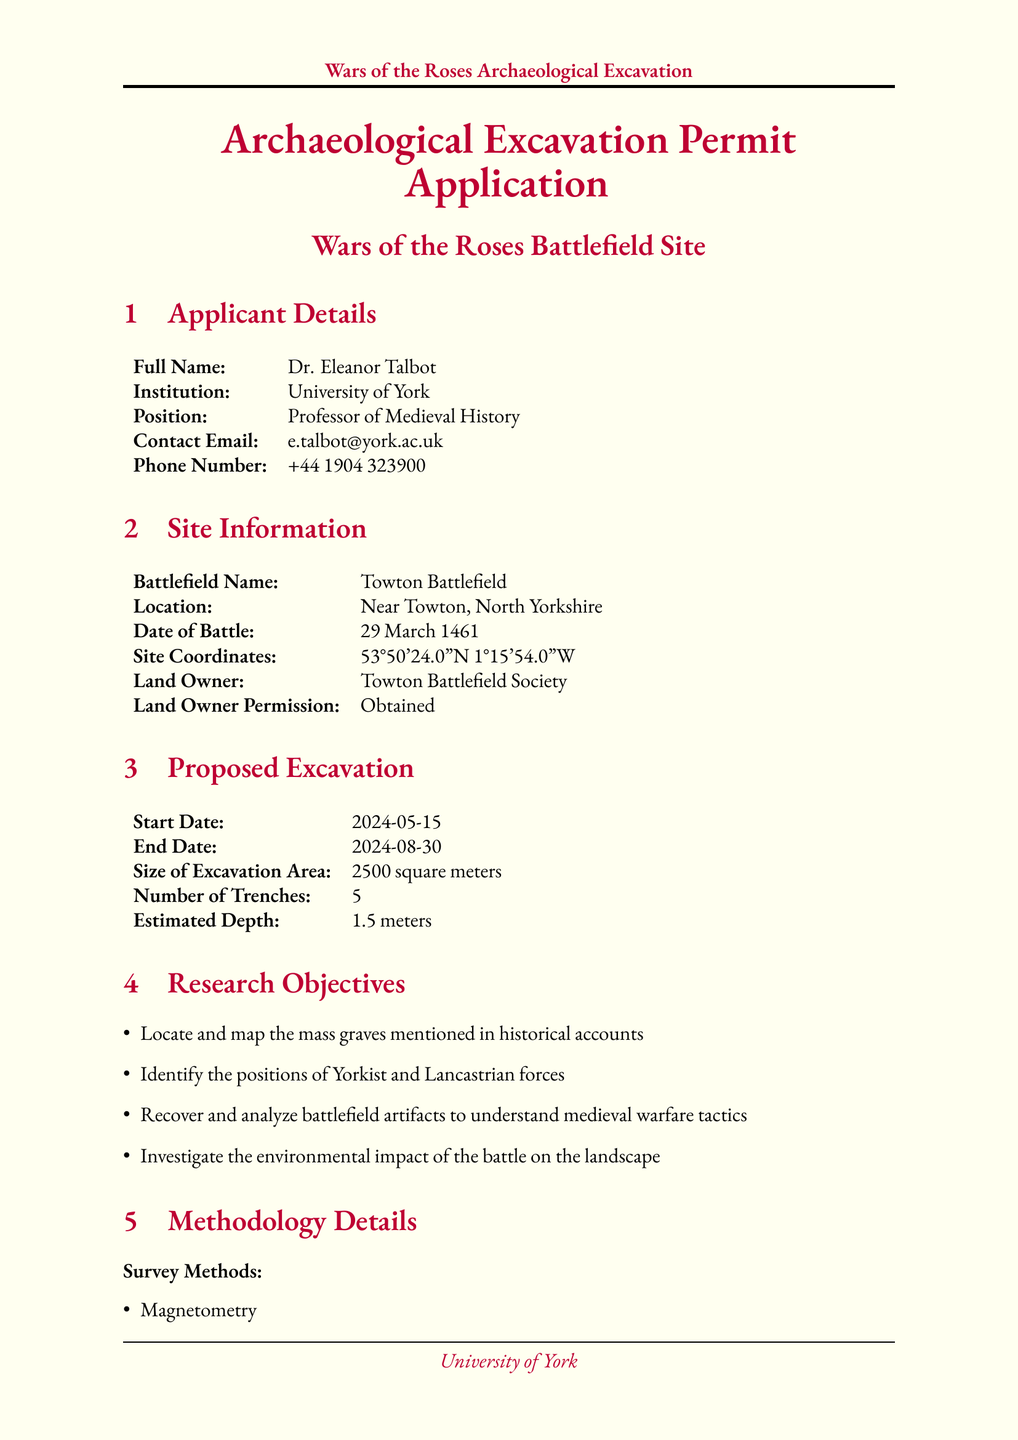What is the name of the applicant? The applicant's name is listed at the top of the document under Applicant Details.
Answer: Dr. Eleanor Talbot What is the battlefield name? The name of the battlefield can be found in the Site Information section.
Answer: Towton Battlefield When did the battle take place? The date of the battle is specified in the Site Information section.
Answer: 29 March 1461 How many trenches are proposed for excavation? The number of trenches is detailed under Proposed Excavation.
Answer: 5 What is the start date of the excavation? The start date is provided in the Proposed Excavation section.
Answer: 2024-05-15 Which survey method is mentioned first? The first method listed under Survey Methods gives insight into the excavation's approach.
Answer: Magnetometry What is the total budget for the excavation? The total budget is found under Funding Information, specifying the financial support for the project.
Answer: £350,000 Who is the Project Director? The Project Director is listed in the Team Composition section, identifying the leadership for the excavation.
Answer: Dr. Richard Neville Where will the artifacts be stored? The artifact storage location is specified in the Conservation Plan section.
Answer: York Castle Museum 